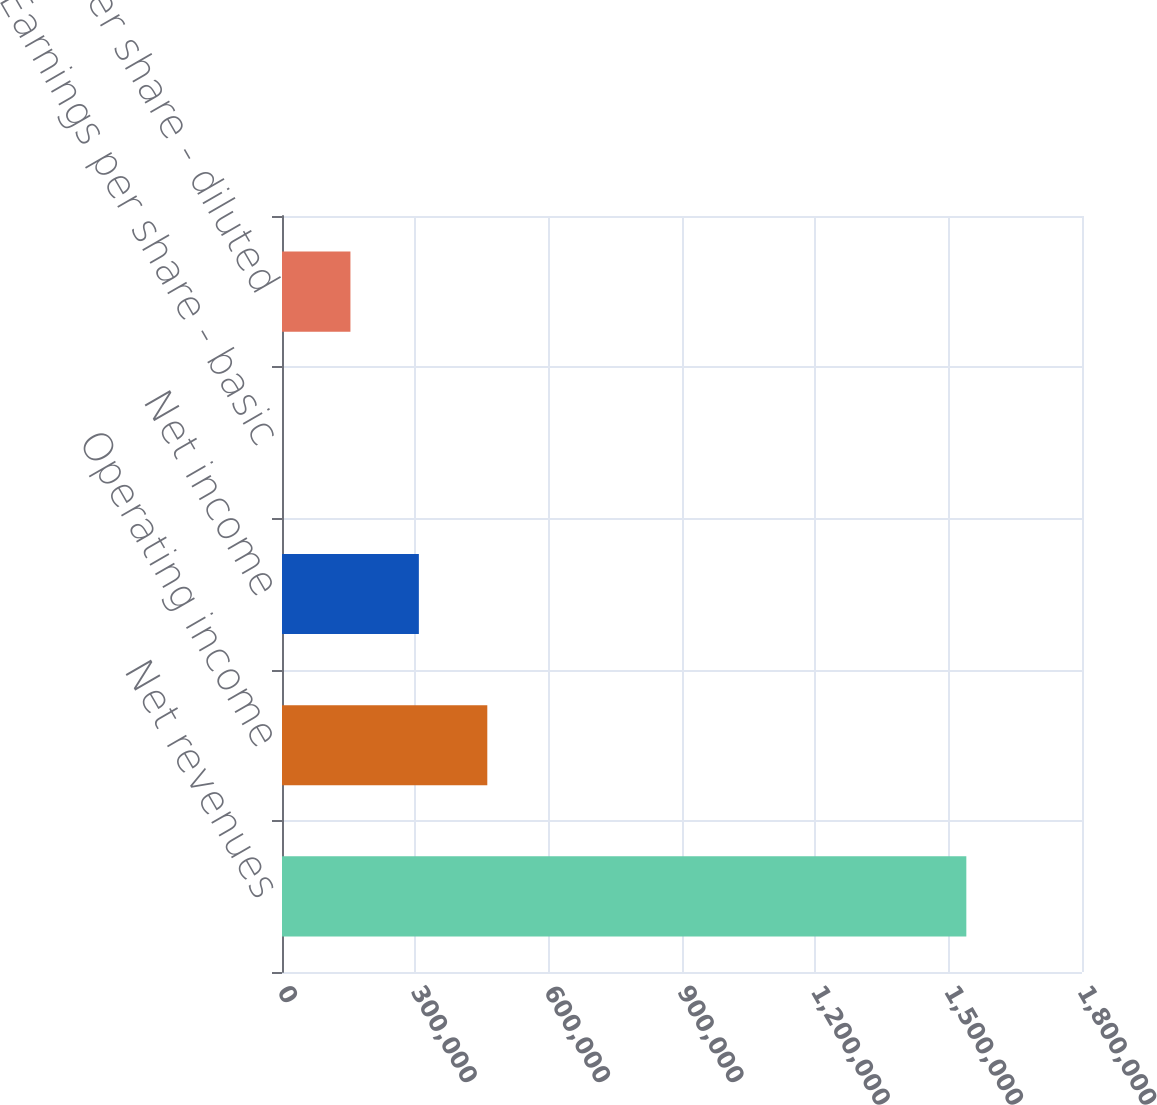Convert chart. <chart><loc_0><loc_0><loc_500><loc_500><bar_chart><fcel>Net revenues<fcel>Operating income<fcel>Net income<fcel>Earnings per share - basic<fcel>Earnings per share - diluted<nl><fcel>1.53974e+06<fcel>461922<fcel>307948<fcel>0.22<fcel>153974<nl></chart> 